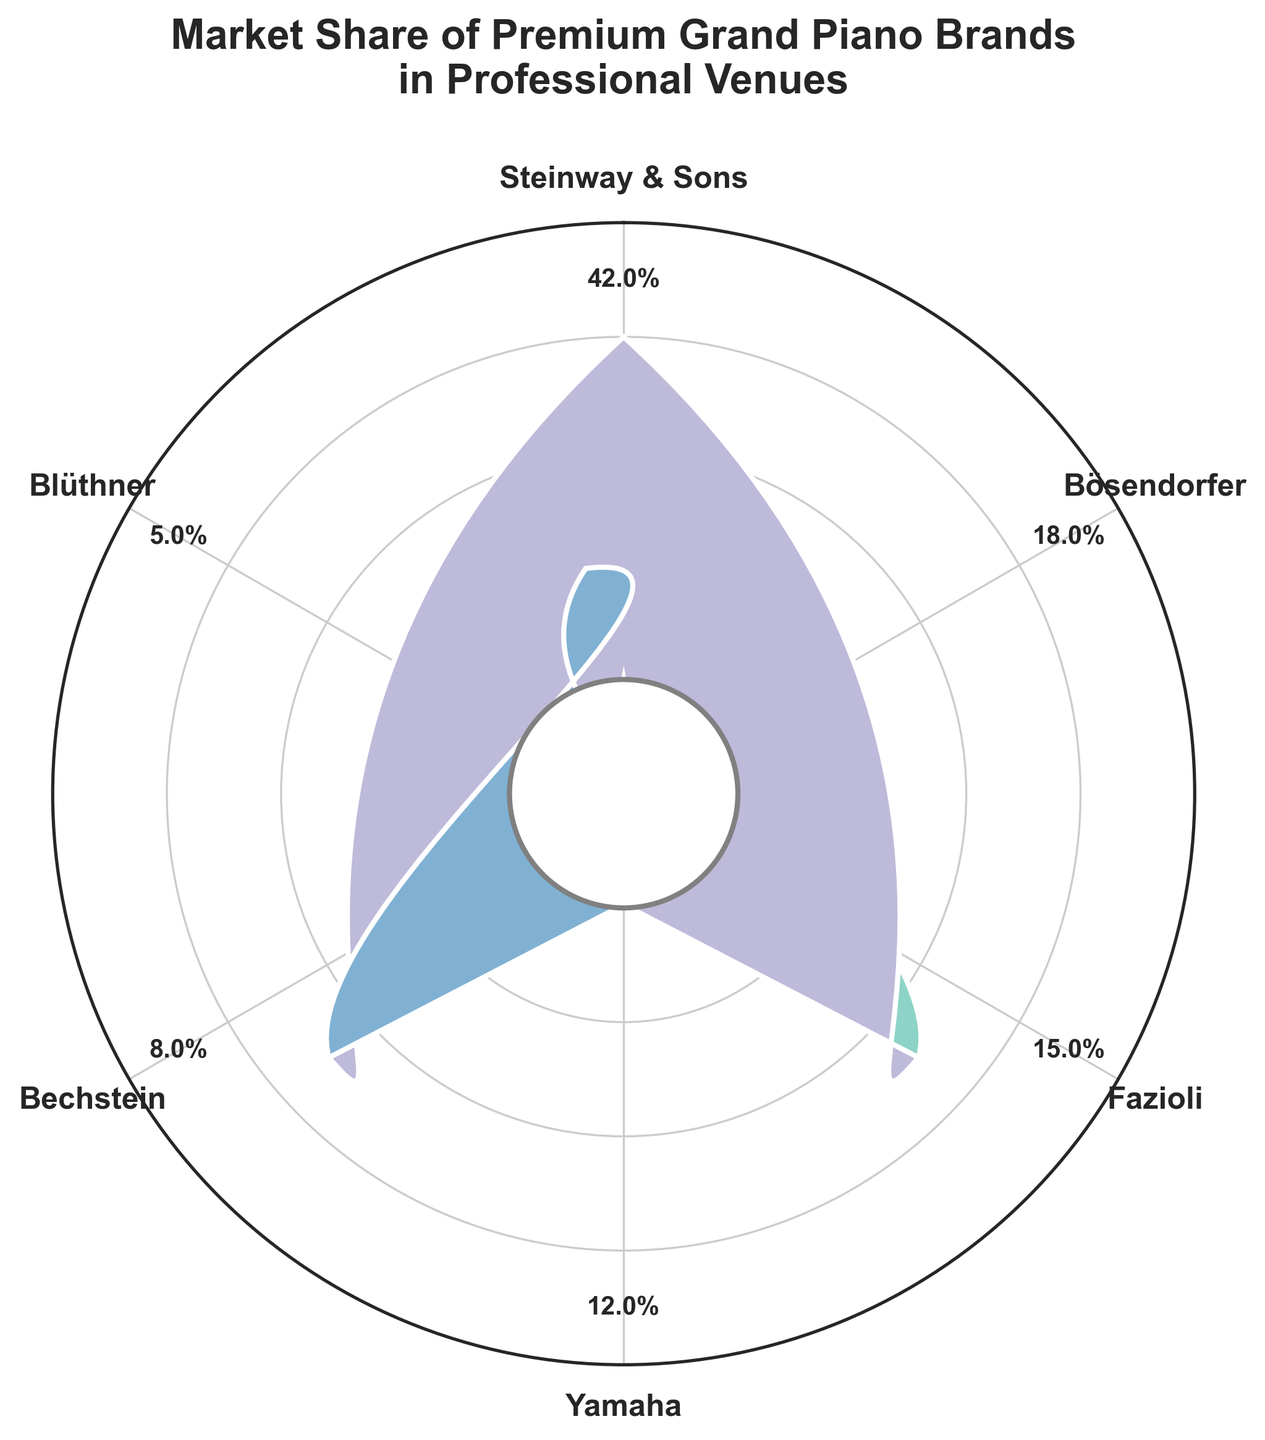What is the market share of Steinway & Sons? According to the figure, the market share of Steinway & Sons is displayed prominently.
Answer: 42% What brand has the second-highest market share? By examining the figure, we can see that Bösendorfer has the second-largest wedge, indicating its market share.
Answer: Bösendorfer What is the combined market share of Yamaha and Blüthner? Yamaha has a 12% market share and Blüthner has a 5% market share. Adding these together gives us 12% + 5% = 17%.
Answer: 17% What is the difference in market share between Fazioli and Bechstein? Fazioli has a 15% market share, whereas Bechstein has an 8% market share. The difference is 15% - 8% = 7%.
Answer: 7% Which two brands have a market share difference of 3%? Comparing the market shares, we can see that the difference between Bösendorfer (18%) and Fazioli (15%) is 3%.
Answer: Bösendorfer and Fazioli What is the total market share represented by the top two brands? Steinway & Sons (42%) and Bösendorfer (18%) together have a market share of 42% + 18% = 60%.
Answer: 60% How does the market share of Bechstein compare to that of Yamaha? Yamaha has a 12% market share, while Bechstein has an 8% market share. Therefore, Yamaha has a greater market share.
Answer: Yamaha has a greater market share Which brand has the smallest market share? Observing the wedges, the smallest one belongs to Blüthner, which has a market share of 5%.
Answer: Blüthner What is the average market share of all brands shown? Summing the market shares of all brands: 42 + 18 + 15 + 12 + 8 + 5 = 100. There are 6 brands, so the average market share is 100 / 6 = 16.67%.
Answer: 16.67% Which brands have a market share greater than 10% but less than 20%? Bösendorfer (18%), Fazioli (15%), and Yamaha (12%) all fall within the range of 10% to 20%.
Answer: Bösendorfer, Fazioli, and Yamaha 